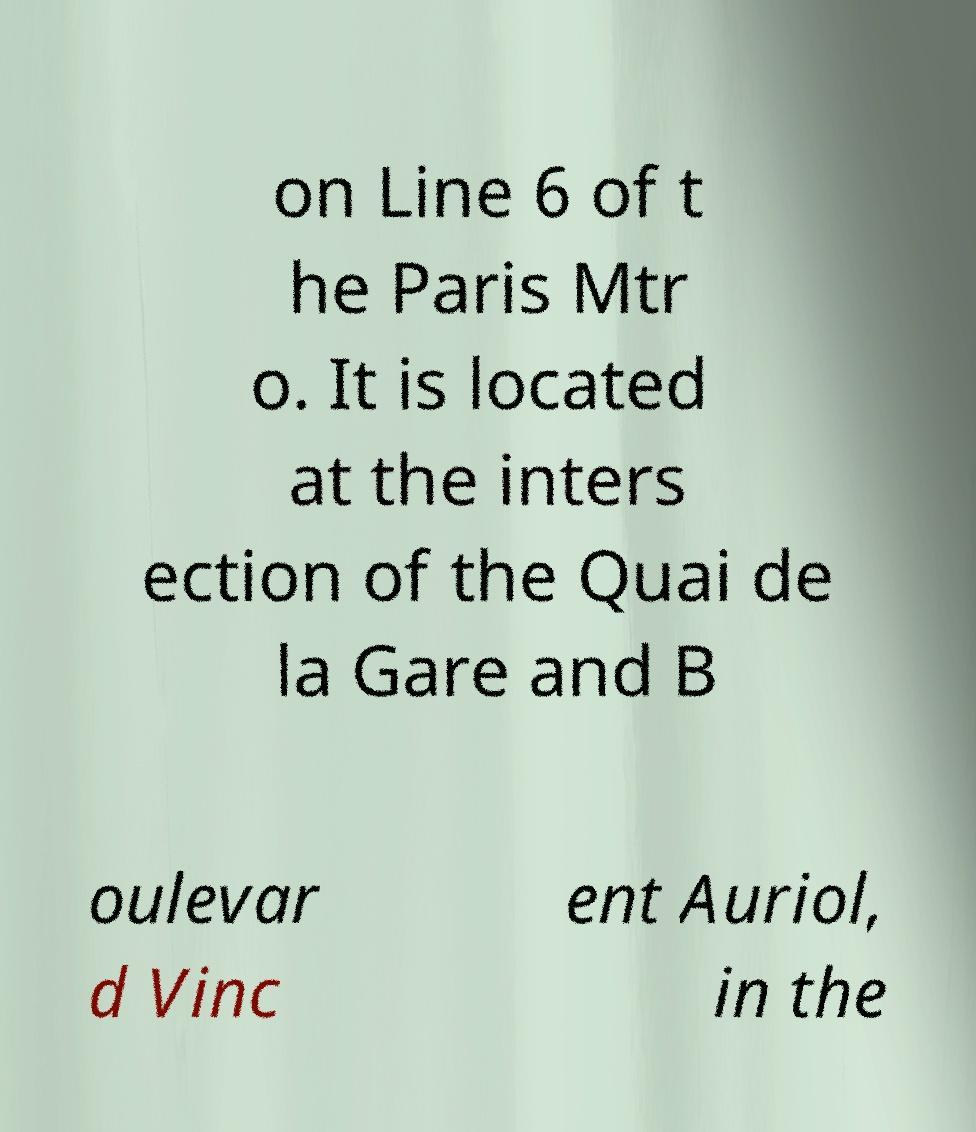Can you accurately transcribe the text from the provided image for me? on Line 6 of t he Paris Mtr o. It is located at the inters ection of the Quai de la Gare and B oulevar d Vinc ent Auriol, in the 